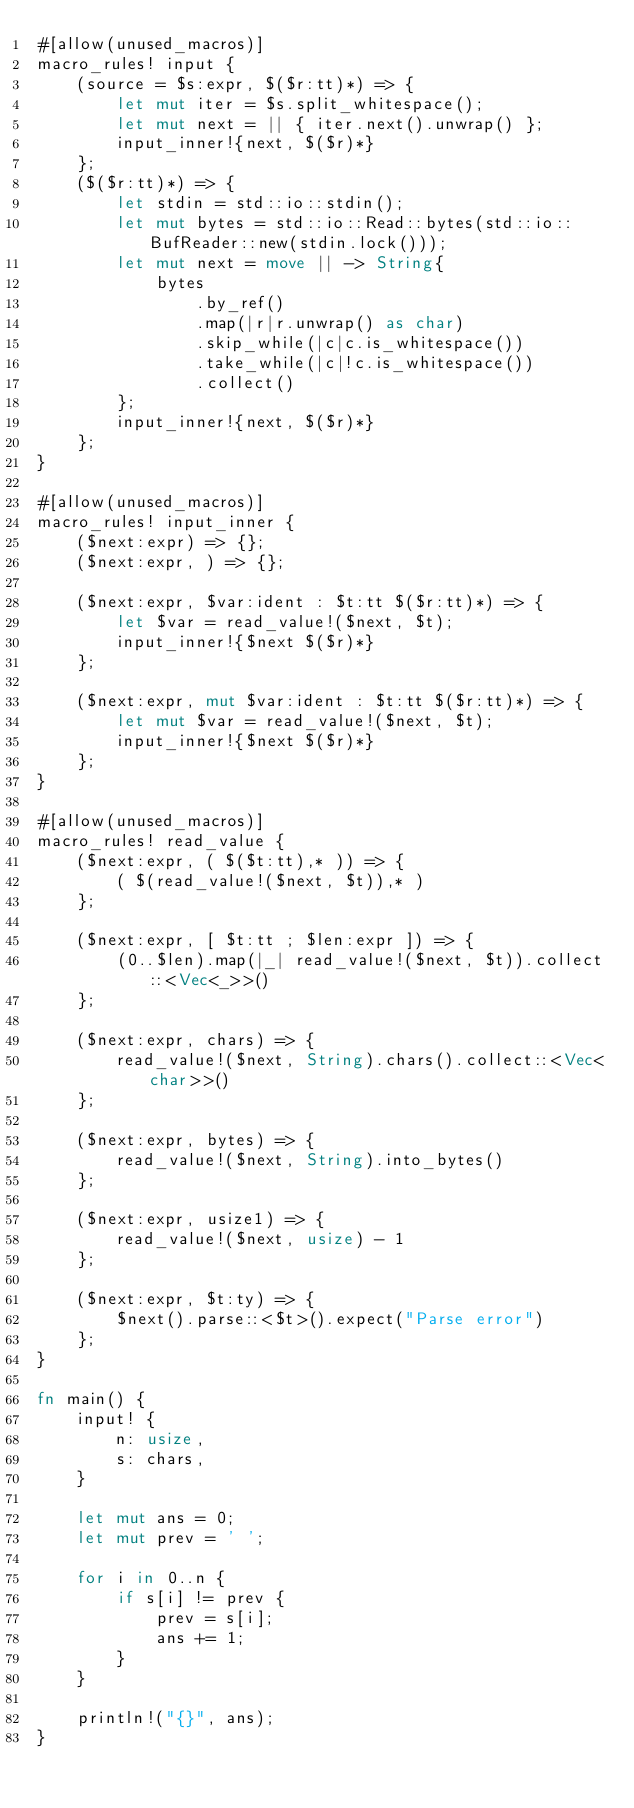<code> <loc_0><loc_0><loc_500><loc_500><_Rust_>#[allow(unused_macros)]
macro_rules! input {
    (source = $s:expr, $($r:tt)*) => {
        let mut iter = $s.split_whitespace();
        let mut next = || { iter.next().unwrap() };
        input_inner!{next, $($r)*}
    };
    ($($r:tt)*) => {
        let stdin = std::io::stdin();
        let mut bytes = std::io::Read::bytes(std::io::BufReader::new(stdin.lock()));
        let mut next = move || -> String{
            bytes
                .by_ref()
                .map(|r|r.unwrap() as char)
                .skip_while(|c|c.is_whitespace())
                .take_while(|c|!c.is_whitespace())
                .collect()
        };
        input_inner!{next, $($r)*}
    };
}

#[allow(unused_macros)]
macro_rules! input_inner {
    ($next:expr) => {};
    ($next:expr, ) => {};

    ($next:expr, $var:ident : $t:tt $($r:tt)*) => {
        let $var = read_value!($next, $t);
        input_inner!{$next $($r)*}
    };

    ($next:expr, mut $var:ident : $t:tt $($r:tt)*) => {
        let mut $var = read_value!($next, $t);
        input_inner!{$next $($r)*}
    };
}

#[allow(unused_macros)]
macro_rules! read_value {
    ($next:expr, ( $($t:tt),* )) => {
        ( $(read_value!($next, $t)),* )
    };

    ($next:expr, [ $t:tt ; $len:expr ]) => {
        (0..$len).map(|_| read_value!($next, $t)).collect::<Vec<_>>()
    };

    ($next:expr, chars) => {
        read_value!($next, String).chars().collect::<Vec<char>>()
    };

    ($next:expr, bytes) => {
        read_value!($next, String).into_bytes()
    };

    ($next:expr, usize1) => {
        read_value!($next, usize) - 1
    };

    ($next:expr, $t:ty) => {
        $next().parse::<$t>().expect("Parse error")
    };
}

fn main() {
    input! {
        n: usize,
        s: chars,
    }

    let mut ans = 0;
    let mut prev = ' ';

    for i in 0..n {
        if s[i] != prev {
            prev = s[i];
            ans += 1;
        }
    }

    println!("{}", ans);
}
</code> 